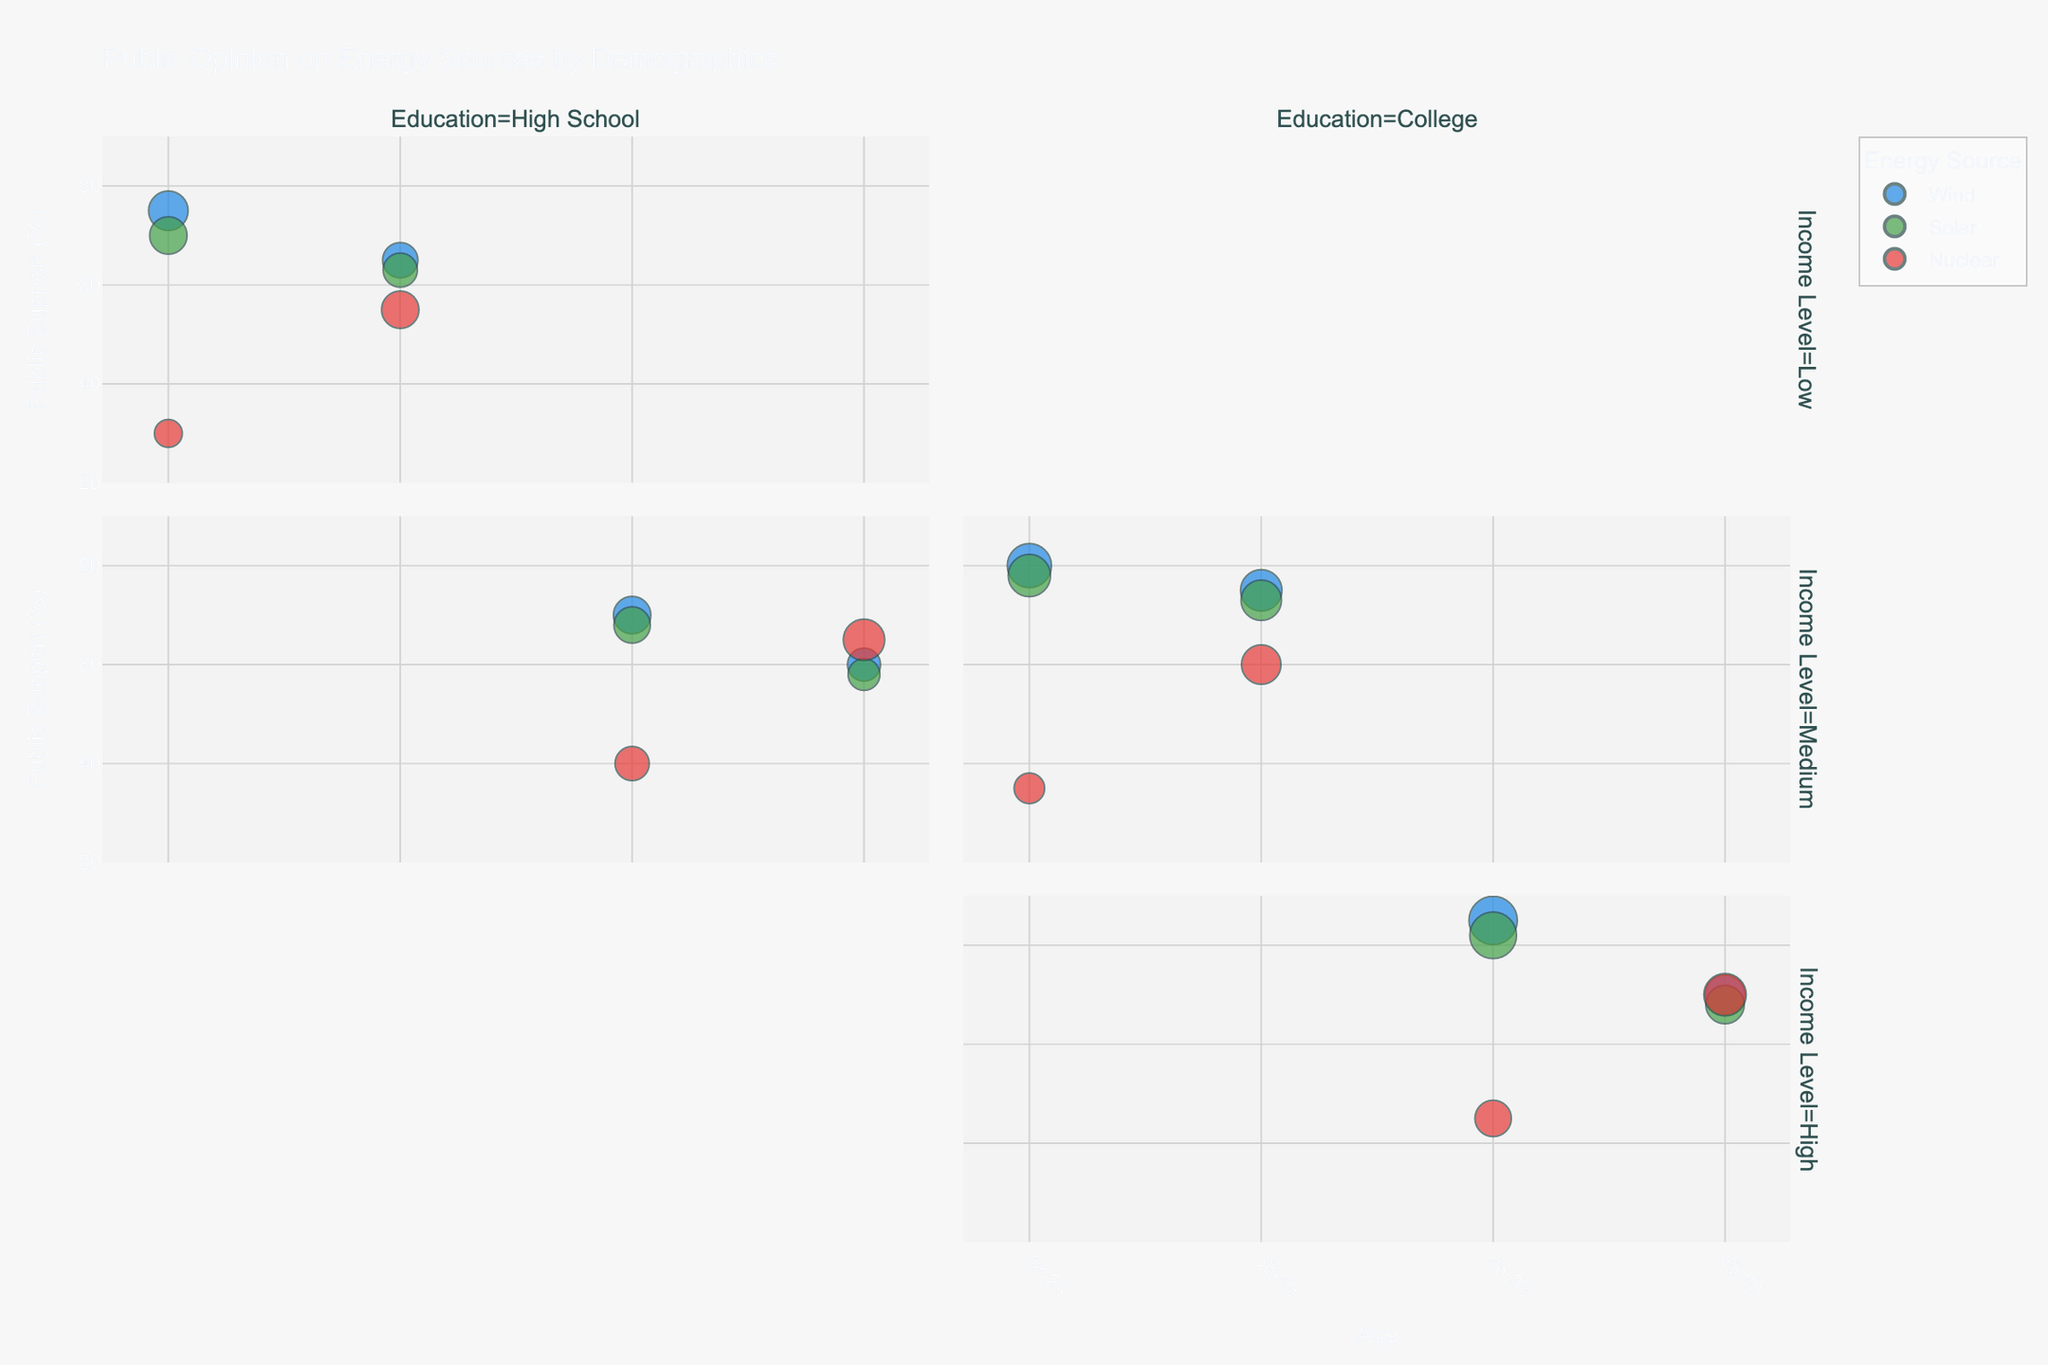What's the title of the figure? The title of the figure is located at the top and summarizes the content of the plot. It is "Public Opinion on Energy Sources by Demographics".
Answer: Public Opinion on Energy Sources by Demographics Which age group shows the highest public support for wind energy? To determine this, look at the vertical position of bubbles representing wind energy for each age group. The highest bubble for wind energy appears in the 26-35 age group.
Answer: 26-35 What is the difference in public support for solar energy between 18-25 year-olds with a college education and 36-45 year-olds with the same education? From the chart, the bubble representing 18-25 year-olds with a college education and solar energy shows a public support of 78%. The bubble for 36-45 year-olds with the same education shows 73%. The difference is 78% - 73%.
Answer: 5% Which demographic has the highest public support for nuclear energy? Examine all bubbles representing nuclear energy to find the highest one. The bubble for 46-60 year-olds with a college education has the highest public support.
Answer: 46-60 College How does public support for solar energy compare between high school and college-educated individuals in the 26-35 age group? Compare the vertical positions of the bubbles for solar energy in the 26-35 age group for high school and college-educated demographics. College-educated individuals show higher support (82%) compared to high school-educated individuals (68%).
Answer: College-educated have higher support What is the average public support for wind energy across all age groups with a college education? Identify and sum the support percentages for wind energy in college-educated demographics: 80%, 85%, 75%, and 70%. Divide by the number of points (4). (80 + 85 + 75 + 70) / 4 = 77.5%.
Answer: 77.5% Which demographic shows the lowest relative importance for nuclear energy? The relative importance is represented by the size of the bubbles. The smallest bubble for nuclear energy appears among 18-25 year-olds with a high school education.
Answer: 18-25 High School, Low What is the total relative importance for wind energy among all 26-35 year-olds? Add the sizes of wind energy bubbles for 26-35 year-olds: 18 (High School, Medium) + 30 (College, High). 18 + 30 = 48.
Answer: 48 Which age group exhibits the highest public support for solar energy within the medium income level? Compare the vertical positions of the solar energy bubbles within the medium income level. The 18-25 age group has the highest support at 78%.
Answer: 18-25 By how much does public support for nuclear energy differ between high school-educated 36-45 year-olds and college-educated 46-60 year-olds? Find the public support percentages for both groups: high school-educated 36-45 year-olds show 55%, and college-educated 46-60 year-olds show 70%. The difference is 70% - 55%.
Answer: 15% 